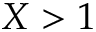Convert formula to latex. <formula><loc_0><loc_0><loc_500><loc_500>X > 1</formula> 